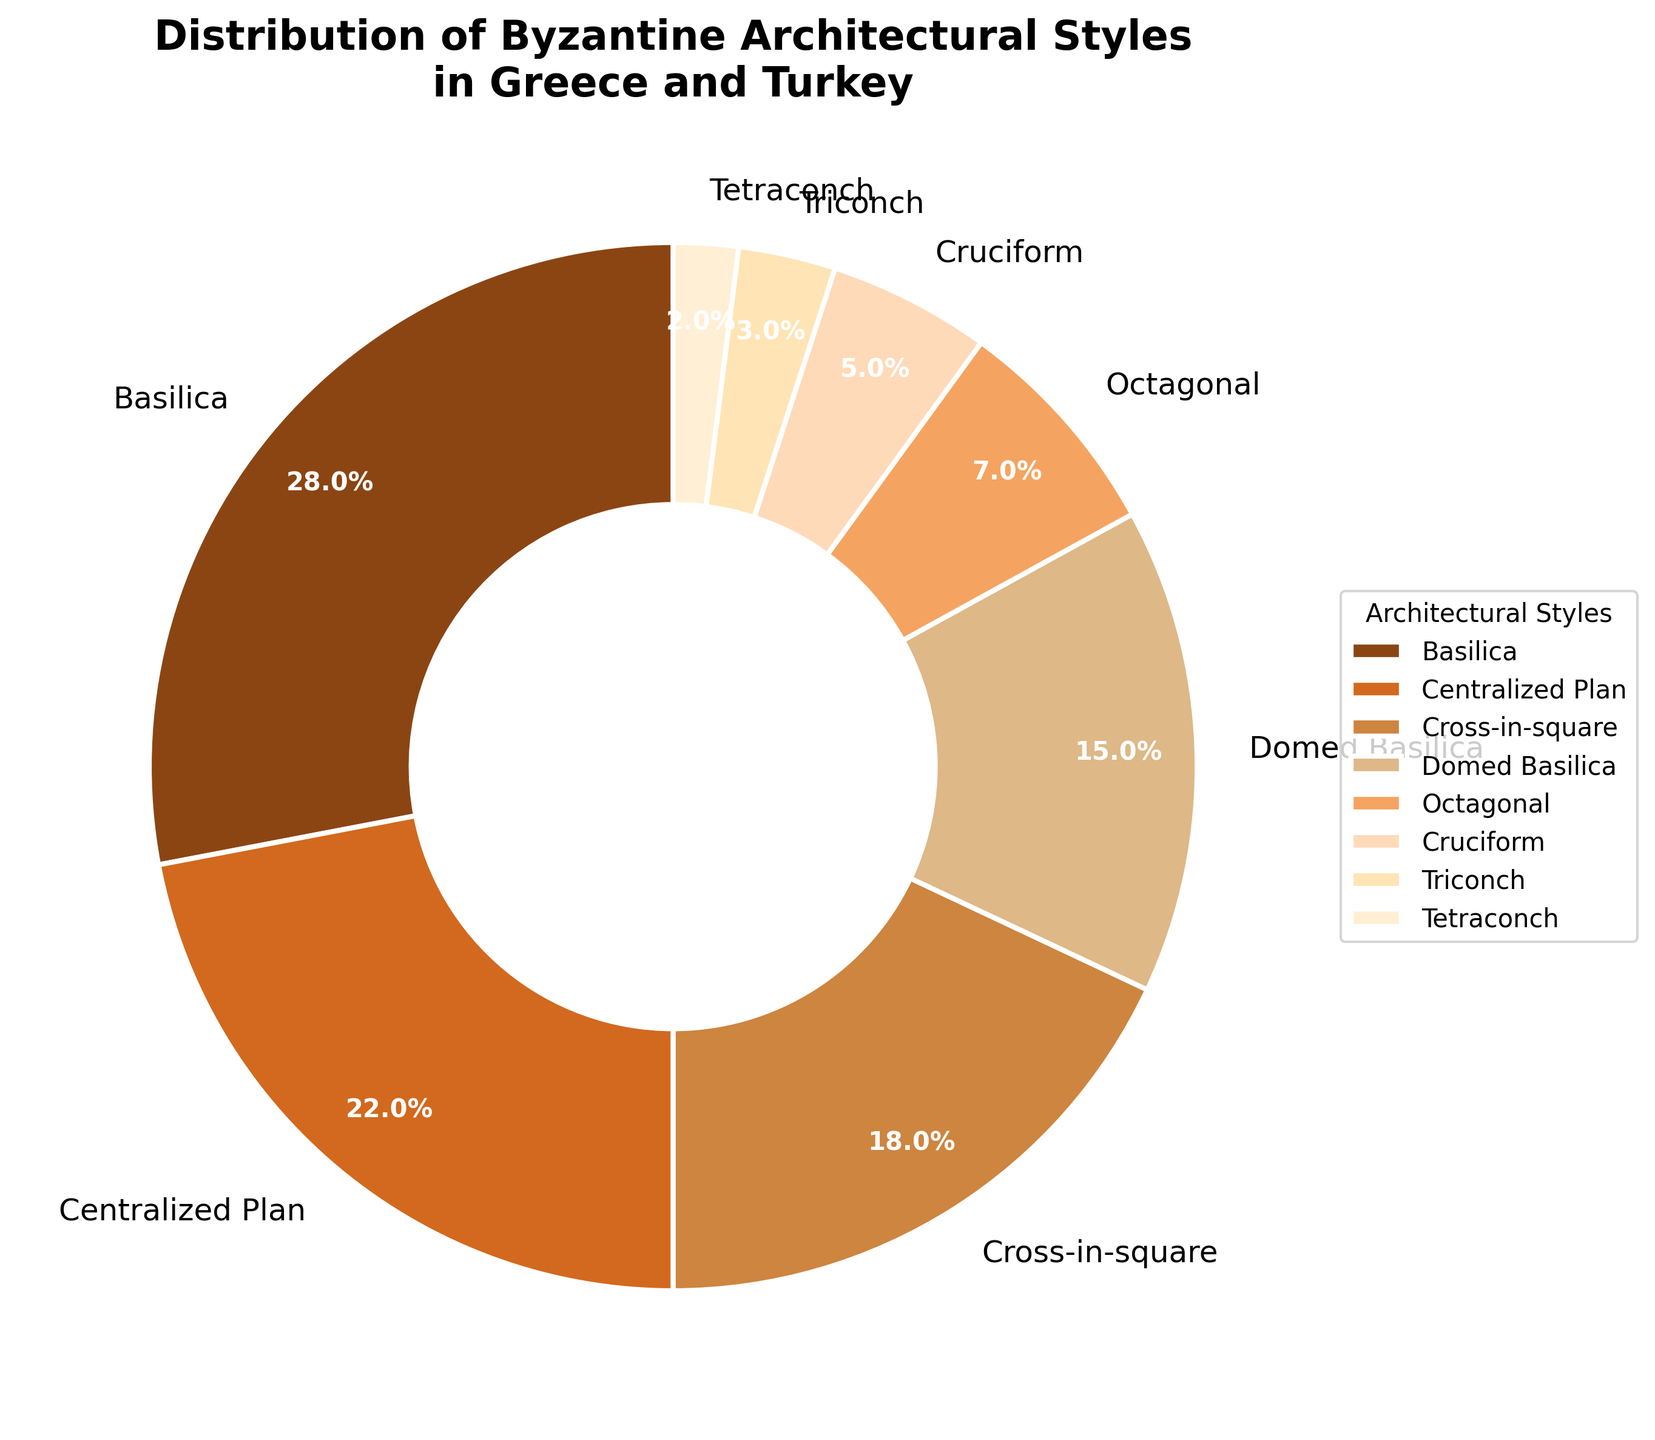Which architectural style has the largest share of preserved structures? To determine the largest share, look for the segment with the highest percentage in the pie chart. The "Basilica" style has 28%, which is the highest.
Answer: Basilica How does the share of "Centralized Plan" compare to "Cross-in-square"? To compare, observe the percentage values of both styles in the chart. "Centralized Plan" has 22%, and "Cross-in-square" has 18%. Since 22% is greater than 18%, "Centralized Plan" has a larger share.
Answer: Centralized Plan has a larger share What is the combined percentage of "Octagonal", "Cruciform", "Triconch", and "Tetraconch" styles? Sum the percentages of these styles: Octagonal (7%), Cruciform (5%), Triconch (3%), and Tetraconch (2%). 7 + 5 + 3 + 2 = 17%.
Answer: 17% Which style has the smallest share, and what is its percentage? Identify the smallest segment from the pie chart. The "Tetraconch" style has the smallest share at 2%.
Answer: Tetraconch, 2% What is the difference in the percentage share between "Basilica" and "Domed Basilica"? Subtract the percentage of "Domed Basilica" from "Basilica". Basilica (28%) - Domed Basilica (15%) = 13%.
Answer: 13% How many architectural styles have a share greater than 20%? Count the number of segments in the chart having percentages above 20%. "Basilica" (28%) and "Centralized Plan" (22%) are greater than 20%, so there are 2 styles.
Answer: 2 Which architectural style shares have proportions closest to each other, and what are their percentages? Find the pairs with the smallest difference in their percentages. "Centralized Plan" (22%) and "Cross-in-square" (18%) are the closest with a difference of 4%.
Answer: Centralized Plan (22%) and Cross-in-square (18%) If you combined the percentages of "Triconch" and "Tetraconch", how would their total share compare to "Octagonal"? Sum the percentages of "Triconch" (3%) and "Tetraconch" (2%) to get 3 + 2 = 5%. Compare this to "Octagonal" which has 7%, so the combined share (5%) is less than "Octagonal" (7%).
Answer: Less than What is the average percentage share of the "Cruciform" and "Triconch" styles? Average the percentages of "Cruciform" (5%) and "Triconch" (3%). (5 + 3) / 2 = 4%.
Answer: 4% Visually, what is the second most prominent color used in the pie chart, and which style does it represent? The second most prominent color can be found by the size of the segment it colors. The "Centralized Plan" style, represented by the second largest segment, has a distinct color, #D2691E (earthy orange).
Answer: Centralized Plan 